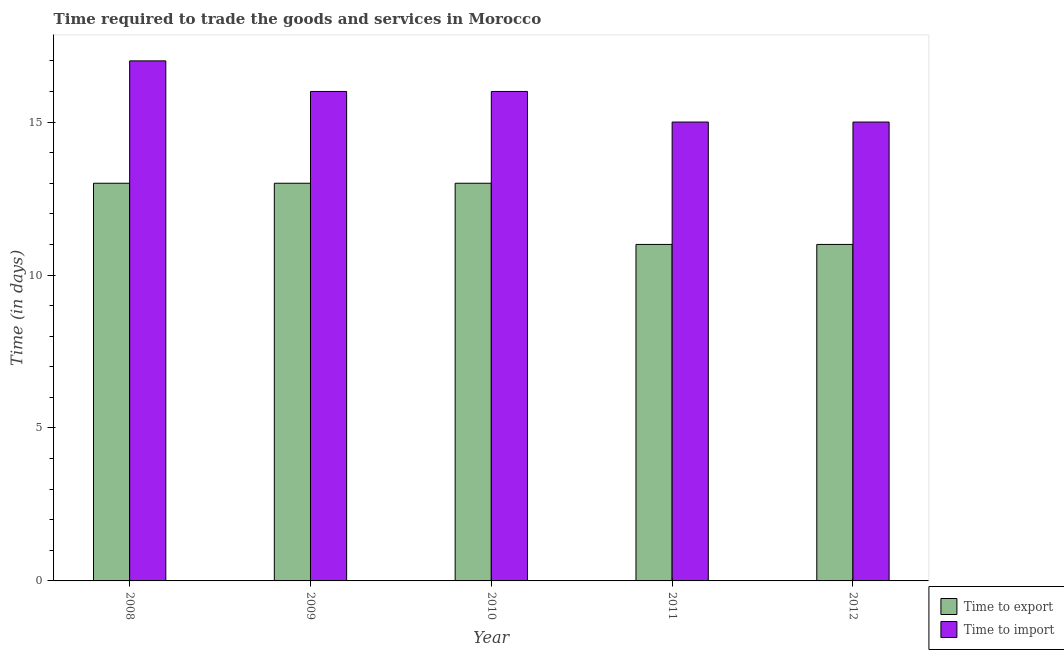How many groups of bars are there?
Ensure brevity in your answer.  5. Are the number of bars on each tick of the X-axis equal?
Provide a short and direct response. Yes. How many bars are there on the 5th tick from the right?
Ensure brevity in your answer.  2. What is the label of the 2nd group of bars from the left?
Offer a very short reply. 2009. In how many cases, is the number of bars for a given year not equal to the number of legend labels?
Your answer should be compact. 0. What is the time to export in 2012?
Provide a succinct answer. 11. Across all years, what is the maximum time to export?
Your response must be concise. 13. Across all years, what is the minimum time to import?
Provide a succinct answer. 15. In which year was the time to import maximum?
Provide a succinct answer. 2008. What is the total time to export in the graph?
Provide a short and direct response. 61. What is the difference between the time to export in 2010 and that in 2012?
Your answer should be very brief. 2. What is the difference between the time to import in 2011 and the time to export in 2010?
Offer a very short reply. -1. What is the average time to import per year?
Offer a very short reply. 15.8. In the year 2011, what is the difference between the time to export and time to import?
Give a very brief answer. 0. In how many years, is the time to import greater than 6 days?
Your response must be concise. 5. Is the time to export in 2008 less than that in 2010?
Your answer should be very brief. No. What is the difference between the highest and the second highest time to import?
Give a very brief answer. 1. What is the difference between the highest and the lowest time to import?
Offer a terse response. 2. What does the 2nd bar from the left in 2008 represents?
Offer a very short reply. Time to import. What does the 2nd bar from the right in 2011 represents?
Keep it short and to the point. Time to export. How many years are there in the graph?
Your answer should be compact. 5. What is the difference between two consecutive major ticks on the Y-axis?
Provide a succinct answer. 5. Does the graph contain any zero values?
Make the answer very short. No. What is the title of the graph?
Provide a succinct answer. Time required to trade the goods and services in Morocco. Does "Constant 2005 US$" appear as one of the legend labels in the graph?
Offer a very short reply. No. What is the label or title of the Y-axis?
Provide a short and direct response. Time (in days). What is the Time (in days) of Time to import in 2011?
Offer a very short reply. 15. Across all years, what is the maximum Time (in days) of Time to export?
Your answer should be very brief. 13. Across all years, what is the maximum Time (in days) of Time to import?
Make the answer very short. 17. Across all years, what is the minimum Time (in days) in Time to export?
Your response must be concise. 11. What is the total Time (in days) of Time to import in the graph?
Your answer should be compact. 79. What is the difference between the Time (in days) in Time to import in 2008 and that in 2010?
Give a very brief answer. 1. What is the difference between the Time (in days) of Time to import in 2008 and that in 2011?
Offer a very short reply. 2. What is the difference between the Time (in days) in Time to import in 2008 and that in 2012?
Your response must be concise. 2. What is the difference between the Time (in days) of Time to import in 2009 and that in 2010?
Give a very brief answer. 0. What is the difference between the Time (in days) of Time to export in 2009 and that in 2011?
Provide a succinct answer. 2. What is the difference between the Time (in days) in Time to export in 2009 and that in 2012?
Your response must be concise. 2. What is the difference between the Time (in days) of Time to import in 2009 and that in 2012?
Offer a terse response. 1. What is the difference between the Time (in days) of Time to export in 2010 and that in 2011?
Ensure brevity in your answer.  2. What is the difference between the Time (in days) in Time to export in 2010 and that in 2012?
Provide a short and direct response. 2. What is the difference between the Time (in days) in Time to export in 2011 and that in 2012?
Your answer should be very brief. 0. What is the difference between the Time (in days) in Time to import in 2011 and that in 2012?
Your response must be concise. 0. What is the difference between the Time (in days) of Time to export in 2008 and the Time (in days) of Time to import in 2009?
Your response must be concise. -3. What is the difference between the Time (in days) of Time to export in 2008 and the Time (in days) of Time to import in 2010?
Ensure brevity in your answer.  -3. What is the difference between the Time (in days) in Time to export in 2008 and the Time (in days) in Time to import in 2011?
Your response must be concise. -2. What is the difference between the Time (in days) in Time to export in 2009 and the Time (in days) in Time to import in 2012?
Your answer should be very brief. -2. What is the difference between the Time (in days) in Time to export in 2010 and the Time (in days) in Time to import in 2012?
Provide a short and direct response. -2. What is the difference between the Time (in days) of Time to export in 2011 and the Time (in days) of Time to import in 2012?
Offer a terse response. -4. What is the average Time (in days) of Time to export per year?
Make the answer very short. 12.2. In the year 2008, what is the difference between the Time (in days) in Time to export and Time (in days) in Time to import?
Your answer should be very brief. -4. In the year 2011, what is the difference between the Time (in days) of Time to export and Time (in days) of Time to import?
Your answer should be very brief. -4. What is the ratio of the Time (in days) of Time to export in 2008 to that in 2009?
Your answer should be very brief. 1. What is the ratio of the Time (in days) of Time to export in 2008 to that in 2010?
Provide a short and direct response. 1. What is the ratio of the Time (in days) in Time to import in 2008 to that in 2010?
Provide a succinct answer. 1.06. What is the ratio of the Time (in days) of Time to export in 2008 to that in 2011?
Give a very brief answer. 1.18. What is the ratio of the Time (in days) of Time to import in 2008 to that in 2011?
Offer a terse response. 1.13. What is the ratio of the Time (in days) of Time to export in 2008 to that in 2012?
Offer a very short reply. 1.18. What is the ratio of the Time (in days) of Time to import in 2008 to that in 2012?
Provide a succinct answer. 1.13. What is the ratio of the Time (in days) in Time to export in 2009 to that in 2010?
Make the answer very short. 1. What is the ratio of the Time (in days) in Time to export in 2009 to that in 2011?
Offer a very short reply. 1.18. What is the ratio of the Time (in days) in Time to import in 2009 to that in 2011?
Make the answer very short. 1.07. What is the ratio of the Time (in days) of Time to export in 2009 to that in 2012?
Keep it short and to the point. 1.18. What is the ratio of the Time (in days) of Time to import in 2009 to that in 2012?
Offer a very short reply. 1.07. What is the ratio of the Time (in days) of Time to export in 2010 to that in 2011?
Offer a very short reply. 1.18. What is the ratio of the Time (in days) of Time to import in 2010 to that in 2011?
Make the answer very short. 1.07. What is the ratio of the Time (in days) of Time to export in 2010 to that in 2012?
Ensure brevity in your answer.  1.18. What is the ratio of the Time (in days) of Time to import in 2010 to that in 2012?
Provide a succinct answer. 1.07. What is the ratio of the Time (in days) of Time to export in 2011 to that in 2012?
Provide a short and direct response. 1. What is the difference between the highest and the second highest Time (in days) in Time to import?
Offer a very short reply. 1. What is the difference between the highest and the lowest Time (in days) of Time to export?
Give a very brief answer. 2. What is the difference between the highest and the lowest Time (in days) of Time to import?
Make the answer very short. 2. 